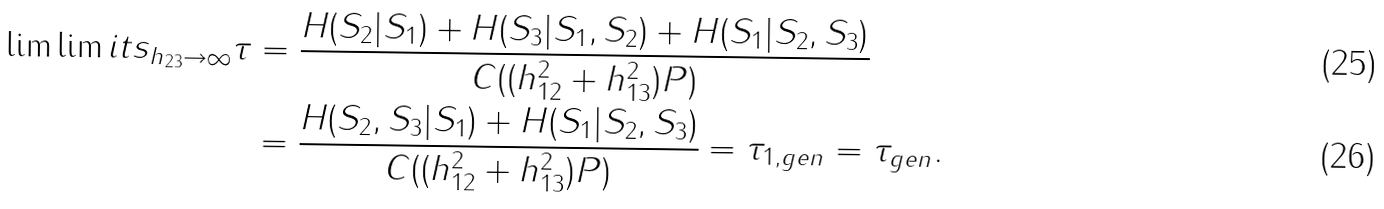<formula> <loc_0><loc_0><loc_500><loc_500>\lim \lim i t s _ { h _ { 2 3 } \rightarrow \infty } \tau & = \frac { H ( S _ { 2 } | S _ { 1 } ) + H ( S _ { 3 } | S _ { 1 } , S _ { 2 } ) + H ( S _ { 1 } | S _ { 2 } , S _ { 3 } ) } { C ( ( h _ { 1 2 } ^ { 2 } + h _ { 1 3 } ^ { 2 } ) P ) } \\ & = \frac { H ( S _ { 2 } , S _ { 3 } | S _ { 1 } ) + H ( S _ { 1 } | S _ { 2 } , S _ { 3 } ) } { C ( ( h _ { 1 2 } ^ { 2 } + h _ { 1 3 } ^ { 2 } ) P ) } = \tau _ { 1 , g e n } = \tau _ { g e n } .</formula> 